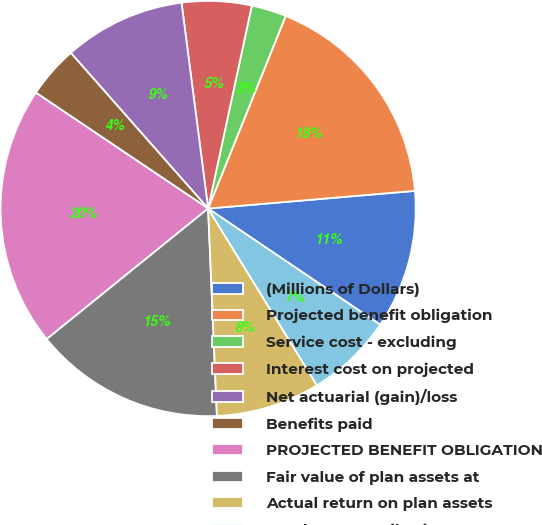<chart> <loc_0><loc_0><loc_500><loc_500><pie_chart><fcel>(Millions of Dollars)<fcel>Projected benefit obligation<fcel>Service cost - excluding<fcel>Interest cost on projected<fcel>Net actuarial (gain)/loss<fcel>Benefits paid<fcel>PROJECTED BENEFIT OBLIGATION<fcel>Fair value of plan assets at<fcel>Actual return on plan assets<fcel>Employer contributions<nl><fcel>10.81%<fcel>17.55%<fcel>2.72%<fcel>5.42%<fcel>9.46%<fcel>4.07%<fcel>20.25%<fcel>14.85%<fcel>8.11%<fcel>6.76%<nl></chart> 